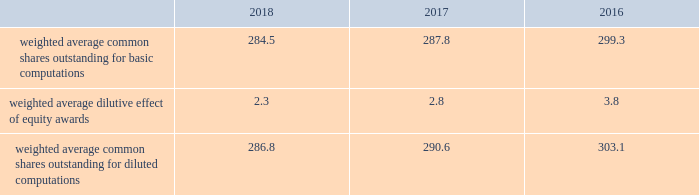Note 2 2013 earnings per share the weighted average number of shares outstanding used to compute earnings per common share were as follows ( in millions ) : .
We compute basic and diluted earnings per common share by dividing net earnings by the respective weighted average number of common shares outstanding for the periods presented .
Our calculation of diluted earnings per common share also includes the dilutive effects for the assumed vesting of outstanding restricted stock units ( rsus ) , performance stock units ( psus ) and exercise of outstanding stock options based on the treasury stock method .
There were no significant anti-dilutive equity awards for the years ended december 31 , 2018 , 2017 and 2016 .
Note 3 2013 acquisition and divestitures consolidation of awe management limited on august 24 , 2016 , we increased our ownership interest in the awe joint venture , which operates the united kingdom 2019s nuclear deterrent program , from 33% ( 33 % ) to 51% ( 51 % ) .
Consequently , we began consolidating awe and our operating results include 100% ( 100 % ) of awe 2019s sales and 51% ( 51 % ) of its operating profit .
Prior to increasing our ownership interest , we accounted for our investment in awe using the equity method of accounting .
Under the equity method , we recognized only 33% ( 33 % ) of awe 2019s earnings or losses and no sales .
Accordingly , prior to august 24 , 2016 , the date we obtained control , we recorded 33% ( 33 % ) of awe 2019s net earnings in our operating results and subsequent to august 24 , 2016 , we recognized 100% ( 100 % ) of awe 2019s sales and 51% ( 51 % ) of its operating profit .
We accounted for this transaction as a 201cstep acquisition 201d ( as defined by u.s .
Gaap ) , which requires us to consolidate and record the assets and liabilities of awe at fair value .
Accordingly , we recorded intangible assets of $ 243 million related to customer relationships , $ 32 million of net liabilities , and noncontrolling interests of $ 107 million .
The intangible assets are being amortized over a period of eight years in accordance with the underlying pattern of economic benefit reflected by the future net cash flows .
In 2016 , we recognized a non-cash net gain of $ 104 million associated with obtaining a controlling interest in awe , which consisted of a $ 127 million pretax gain recognized in the operating results of our space business segment and $ 23 million of tax-related items at our corporate office .
The gain represented the fair value of our 51% ( 51 % ) interest in awe , less the carrying value of our previously held investment in awe and deferred taxes .
The gain was recorded in other income , net on our consolidated statements of earnings .
The fair value of awe ( including the intangible assets ) , our controlling interest , and the noncontrolling interests were determined using the income approach .
Divestiture of the information systems & global solutions business on august 16 , 2016 , we divested our former is&gs business , which merged with leidos , in a reverse morris trust transaction ( the 201ctransaction 201d ) .
The transaction was completed in a multi-step process pursuant to which we initially contributed the is&gs business to abacus innovations corporation ( abacus ) , a wholly owned subsidiary of lockheed martin created to facilitate the transaction , and the common stock of abacus was distributed to participating lockheed martin stockholders through an exchange offer .
Under the terms of the exchange offer , lockheed martin stockholders had the option to exchange shares of lockheed martin common stock for shares of abacus common stock .
At the conclusion of the exchange offer , all shares of abacus common stock were exchanged for 9369694 shares of lockheed martin common stock held by lockheed martin stockholders that elected to participate in the exchange .
The shares of lockheed martin common stock that were exchanged and accepted were retired , reducing the number of shares of our common stock outstanding by approximately 3% ( 3 % ) .
Following the exchange offer , abacus merged with a subsidiary of leidos , with abacus continuing as the surviving corporation and a wholly-owned subsidiary of leidos .
As part of the merger , each share of abacus common stock was automatically converted into one share of leidos common stock .
We did not receive any shares of leidos common stock as part of the transaction and do not hold any shares of leidos or abacus common stock following the transaction .
Based on an opinion of outside tax counsel , subject to customary qualifications and based on factual representations , the exchange offer and merger will qualify as tax-free transactions to lockheed martin and its stockholders , except to the extent that cash was paid to lockheed martin stockholders in lieu of fractional shares .
In connection with the transaction , abacus borrowed an aggregate principal amount of approximately $ 1.84 billion under term loan facilities with third party financial institutions , the proceeds of which were used to make a one-time special cash payment of $ 1.80 billion to lockheed martin and to pay associated borrowing fees and expenses .
The entire special cash payment was used to repay debt , pay dividends and repurchase stock during the third and fourth quarters of 2016 .
The obligations under the abacus term loan facilities were guaranteed by leidos as part of the transaction. .
What is the percentage change in weighted average common shares outstanding for basic computations from 2017 to 2018? 
Computations: ((284.5 - 287.8) / 287.8)
Answer: -0.01147. 